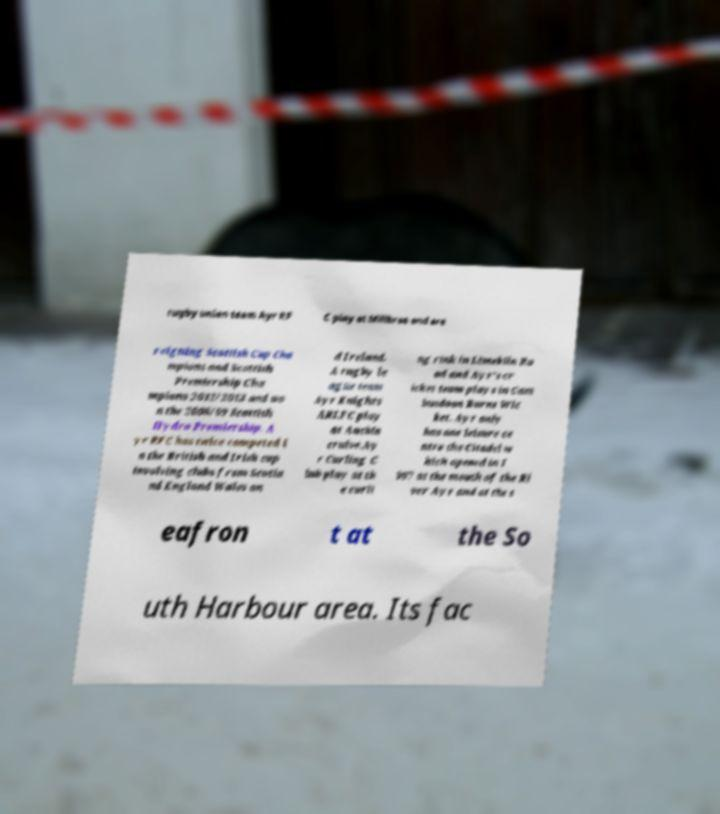Can you read and provide the text displayed in the image?This photo seems to have some interesting text. Can you extract and type it out for me? rugby union team Ayr RF C play at Millbrae and are reigning Scottish Cup Cha mpions and Scottish Premiership Cha mpions 2012/2013 and wo n the 2008/09 Scottish Hydro Premiership. A yr RFC has twice competed i n the British and Irish cup involving clubs from Scotla nd England Wales an d Ireland. A rugby le ague team Ayr Knights ARLFC play at Auchin cruive.Ay r Curling C lub play at th e curli ng rink in Limekiln Ro ad and Ayr's cr icket team plays in Cam busdoon Burns Wic ket. Ayr only has one leisure ce ntre the Citadel w hich opened in 1 997 at the mouth of the Ri ver Ayr and at the s eafron t at the So uth Harbour area. Its fac 